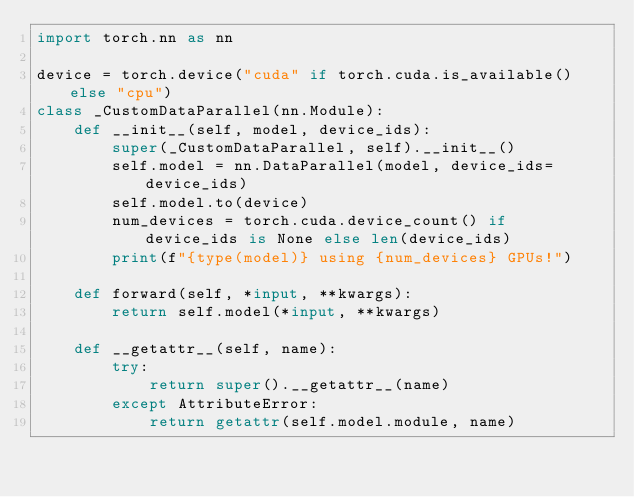<code> <loc_0><loc_0><loc_500><loc_500><_Python_>import torch.nn as nn

device = torch.device("cuda" if torch.cuda.is_available() else "cpu")
class _CustomDataParallel(nn.Module):
    def __init__(self, model, device_ids):
        super(_CustomDataParallel, self).__init__()
        self.model = nn.DataParallel(model, device_ids=device_ids)
        self.model.to(device)
        num_devices = torch.cuda.device_count() if device_ids is None else len(device_ids)
        print(f"{type(model)} using {num_devices} GPUs!")

    def forward(self, *input, **kwargs):
        return self.model(*input, **kwargs)

    def __getattr__(self, name):
        try:
            return super().__getattr__(name)
        except AttributeError:
            return getattr(self.model.module, name)</code> 